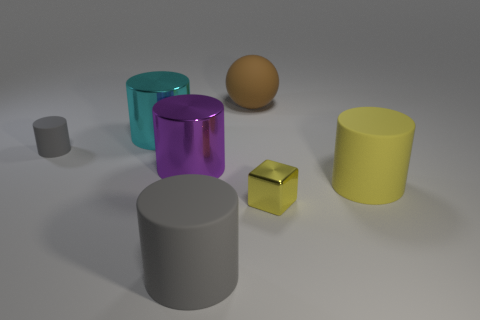What number of other things are the same shape as the purple object?
Offer a terse response. 4. How many other objects are there of the same material as the tiny cube?
Your response must be concise. 2. There is a yellow cylinder that is in front of the gray cylinder that is behind the large rubber cylinder that is on the left side of the tiny metal cube; what is its material?
Offer a very short reply. Rubber. Do the tiny yellow object and the big yellow cylinder have the same material?
Your answer should be very brief. No. What number of cylinders are shiny objects or brown objects?
Your answer should be very brief. 2. What is the color of the large matte cylinder on the right side of the big gray matte object?
Ensure brevity in your answer.  Yellow. What number of metallic objects are either large gray spheres or large purple cylinders?
Your answer should be compact. 1. The big cylinder behind the large purple metal cylinder that is right of the cyan metallic cylinder is made of what material?
Keep it short and to the point. Metal. There is another cylinder that is the same color as the tiny matte cylinder; what is it made of?
Offer a terse response. Rubber. The small block is what color?
Your response must be concise. Yellow. 